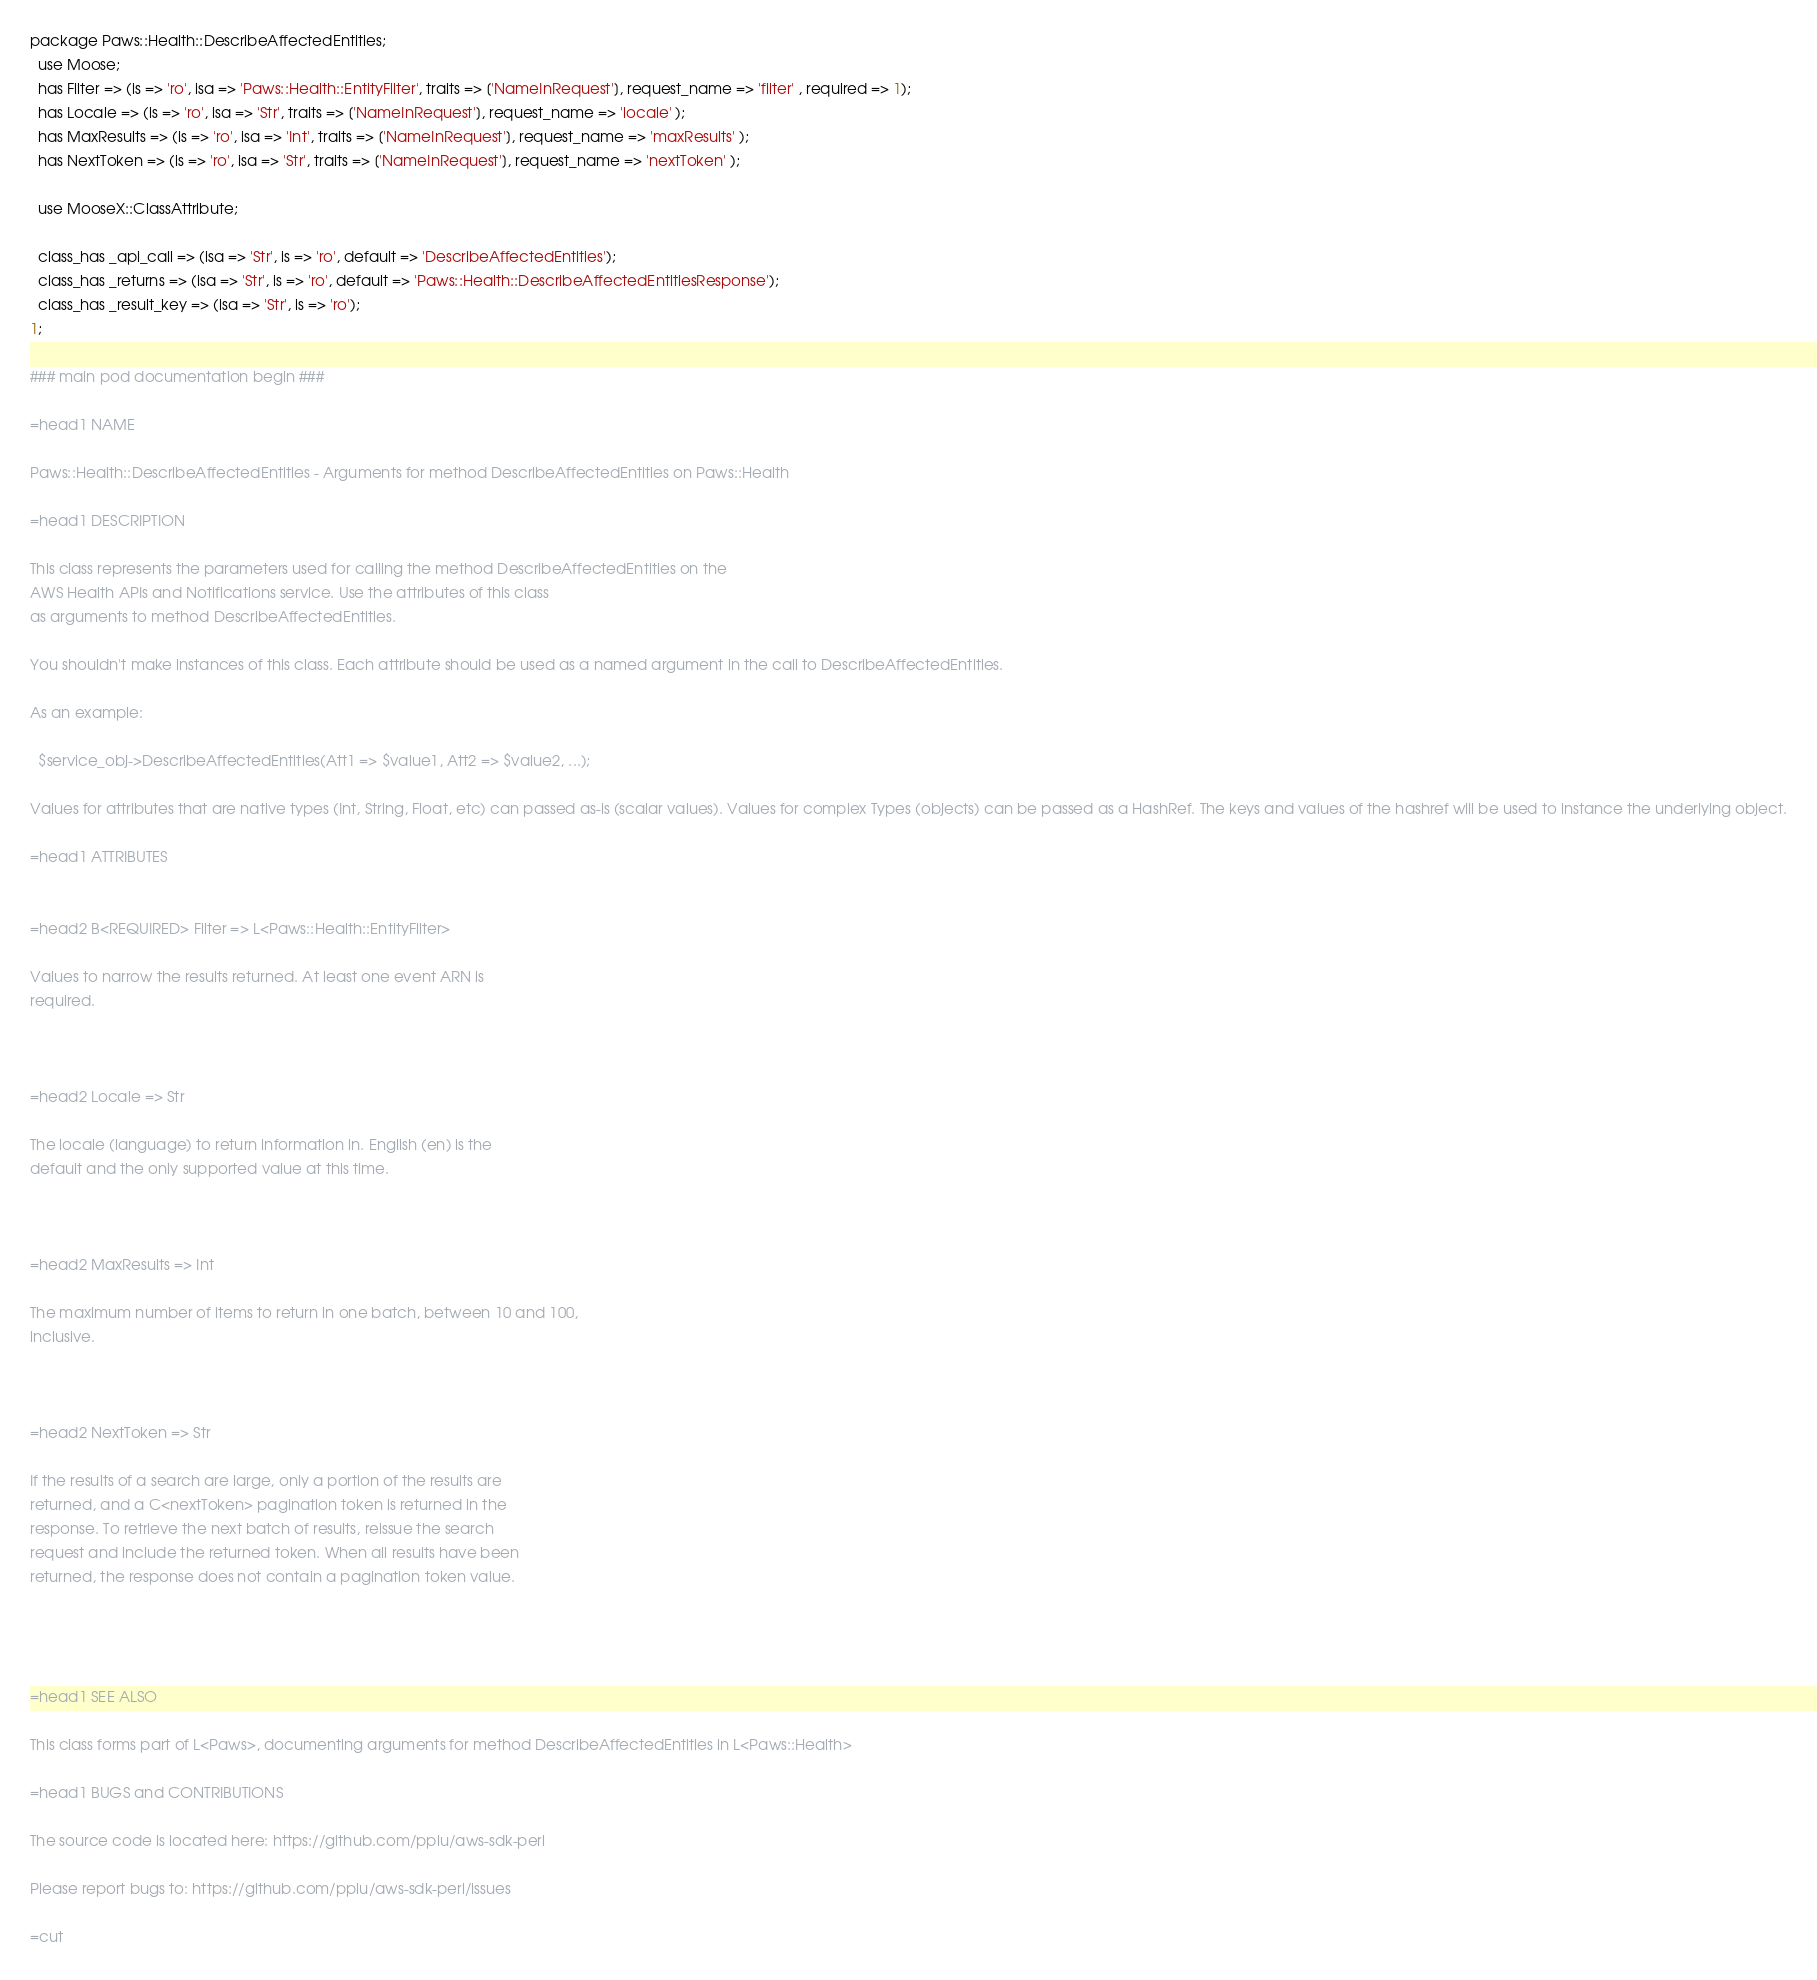Convert code to text. <code><loc_0><loc_0><loc_500><loc_500><_Perl_>
package Paws::Health::DescribeAffectedEntities;
  use Moose;
  has Filter => (is => 'ro', isa => 'Paws::Health::EntityFilter', traits => ['NameInRequest'], request_name => 'filter' , required => 1);
  has Locale => (is => 'ro', isa => 'Str', traits => ['NameInRequest'], request_name => 'locale' );
  has MaxResults => (is => 'ro', isa => 'Int', traits => ['NameInRequest'], request_name => 'maxResults' );
  has NextToken => (is => 'ro', isa => 'Str', traits => ['NameInRequest'], request_name => 'nextToken' );

  use MooseX::ClassAttribute;

  class_has _api_call => (isa => 'Str', is => 'ro', default => 'DescribeAffectedEntities');
  class_has _returns => (isa => 'Str', is => 'ro', default => 'Paws::Health::DescribeAffectedEntitiesResponse');
  class_has _result_key => (isa => 'Str', is => 'ro');
1;

### main pod documentation begin ###

=head1 NAME

Paws::Health::DescribeAffectedEntities - Arguments for method DescribeAffectedEntities on Paws::Health

=head1 DESCRIPTION

This class represents the parameters used for calling the method DescribeAffectedEntities on the 
AWS Health APIs and Notifications service. Use the attributes of this class
as arguments to method DescribeAffectedEntities.

You shouldn't make instances of this class. Each attribute should be used as a named argument in the call to DescribeAffectedEntities.

As an example:

  $service_obj->DescribeAffectedEntities(Att1 => $value1, Att2 => $value2, ...);

Values for attributes that are native types (Int, String, Float, etc) can passed as-is (scalar values). Values for complex Types (objects) can be passed as a HashRef. The keys and values of the hashref will be used to instance the underlying object.

=head1 ATTRIBUTES


=head2 B<REQUIRED> Filter => L<Paws::Health::EntityFilter>

Values to narrow the results returned. At least one event ARN is
required.



=head2 Locale => Str

The locale (language) to return information in. English (en) is the
default and the only supported value at this time.



=head2 MaxResults => Int

The maximum number of items to return in one batch, between 10 and 100,
inclusive.



=head2 NextToken => Str

If the results of a search are large, only a portion of the results are
returned, and a C<nextToken> pagination token is returned in the
response. To retrieve the next batch of results, reissue the search
request and include the returned token. When all results have been
returned, the response does not contain a pagination token value.




=head1 SEE ALSO

This class forms part of L<Paws>, documenting arguments for method DescribeAffectedEntities in L<Paws::Health>

=head1 BUGS and CONTRIBUTIONS

The source code is located here: https://github.com/pplu/aws-sdk-perl

Please report bugs to: https://github.com/pplu/aws-sdk-perl/issues

=cut

</code> 